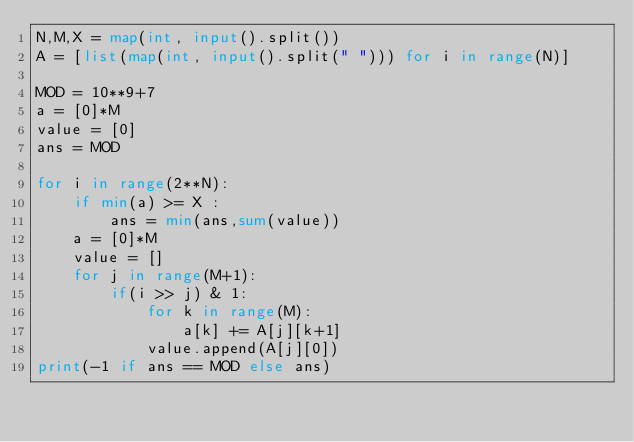Convert code to text. <code><loc_0><loc_0><loc_500><loc_500><_Python_>N,M,X = map(int, input().split())
A = [list(map(int, input().split(" "))) for i in range(N)]

MOD = 10**9+7
a = [0]*M
value = [0]
ans = MOD

for i in range(2**N):
    if min(a) >= X :
        ans = min(ans,sum(value))
    a = [0]*M
    value = []
    for j in range(M+1):
        if(i >> j) & 1:
            for k in range(M):
                a[k] += A[j][k+1]
            value.append(A[j][0])
print(-1 if ans == MOD else ans)
</code> 